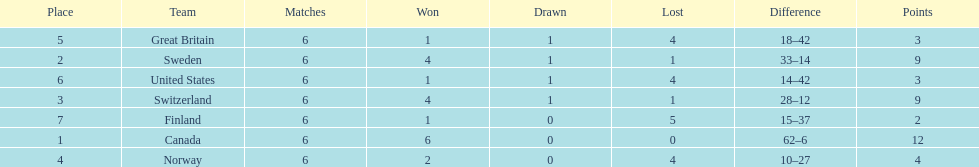What was the number of points won by great britain? 3. 